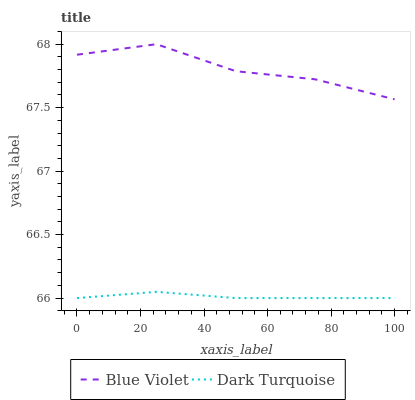Does Dark Turquoise have the minimum area under the curve?
Answer yes or no. Yes. Does Blue Violet have the maximum area under the curve?
Answer yes or no. Yes. Does Blue Violet have the minimum area under the curve?
Answer yes or no. No. Is Dark Turquoise the smoothest?
Answer yes or no. Yes. Is Blue Violet the roughest?
Answer yes or no. Yes. Is Blue Violet the smoothest?
Answer yes or no. No. Does Blue Violet have the lowest value?
Answer yes or no. No. Does Blue Violet have the highest value?
Answer yes or no. Yes. Is Dark Turquoise less than Blue Violet?
Answer yes or no. Yes. Is Blue Violet greater than Dark Turquoise?
Answer yes or no. Yes. Does Dark Turquoise intersect Blue Violet?
Answer yes or no. No. 